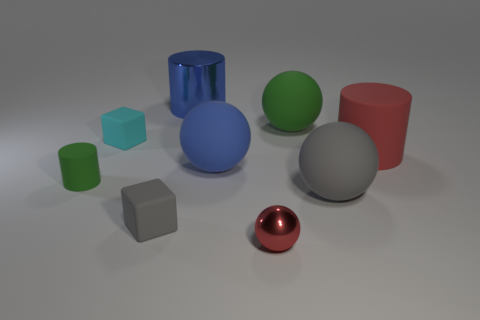Does the large green rubber object have the same shape as the green rubber thing on the left side of the tiny red object?
Offer a terse response. No. Are there more red metallic balls that are behind the small metal thing than big brown matte cubes?
Make the answer very short. No. Are there fewer big red matte cylinders on the left side of the large matte cylinder than purple metal objects?
Provide a short and direct response. No. How many matte cylinders are the same color as the metal cylinder?
Provide a succinct answer. 0. There is a object that is behind the red rubber cylinder and to the left of the big blue cylinder; what is its material?
Provide a short and direct response. Rubber. Do the small cube that is in front of the tiny cyan thing and the small rubber thing that is behind the big red matte cylinder have the same color?
Offer a terse response. No. What number of yellow objects are either small matte blocks or small rubber objects?
Offer a very short reply. 0. Is the number of small gray cubes that are left of the small metallic sphere less than the number of green matte spheres left of the big blue rubber ball?
Offer a very short reply. No. Is there a blue shiny cylinder that has the same size as the cyan thing?
Give a very brief answer. No. Does the blue cylinder that is left of the blue rubber ball have the same size as the green rubber ball?
Provide a short and direct response. Yes. 